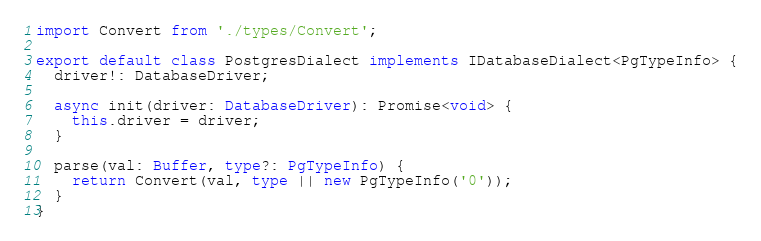<code> <loc_0><loc_0><loc_500><loc_500><_TypeScript_>import Convert from './types/Convert';

export default class PostgresDialect implements IDatabaseDialect<PgTypeInfo> {
  driver!: DatabaseDriver;

  async init(driver: DatabaseDriver): Promise<void> {
    this.driver = driver;
  }

  parse(val: Buffer, type?: PgTypeInfo) {
    return Convert(val, type || new PgTypeInfo('0'));
  }
}
</code> 